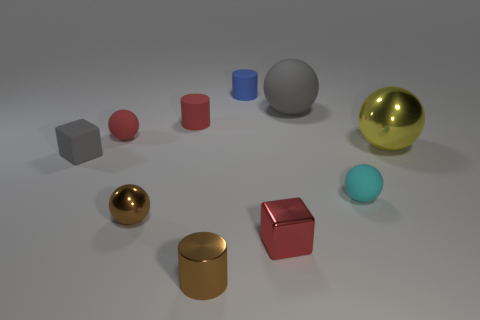Subtract all matte cylinders. How many cylinders are left? 1 Subtract all red cylinders. How many cylinders are left? 2 Subtract all blocks. How many objects are left? 8 Subtract 1 blocks. How many blocks are left? 1 Add 7 gray matte balls. How many gray matte balls are left? 8 Add 2 tiny objects. How many tiny objects exist? 10 Subtract 0 brown blocks. How many objects are left? 10 Subtract all cyan cylinders. Subtract all purple cubes. How many cylinders are left? 3 Subtract all cyan spheres. How many red blocks are left? 1 Subtract all tiny cyan objects. Subtract all gray blocks. How many objects are left? 8 